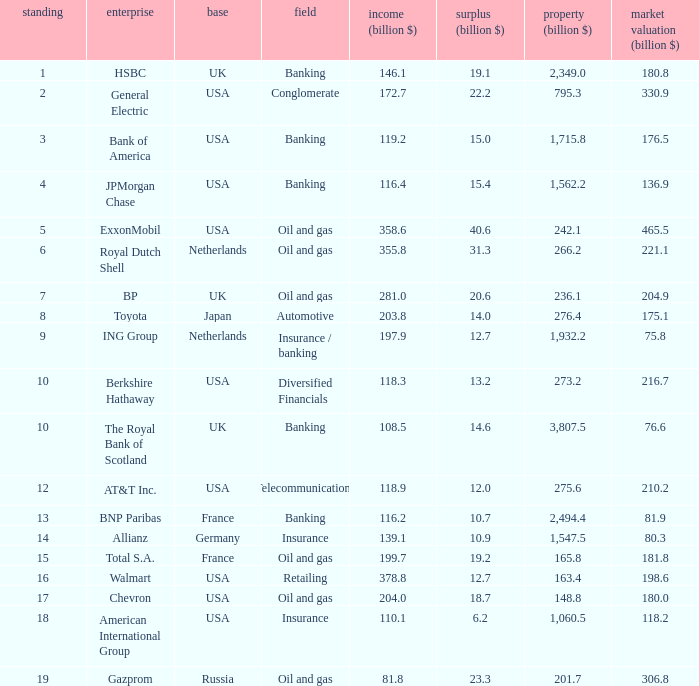What are the profits in billions for Berkshire Hathaway?  13.2. 